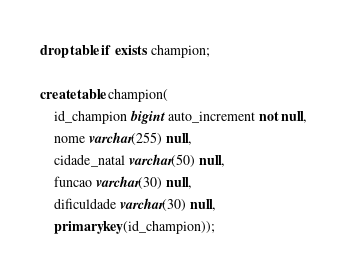<code> <loc_0><loc_0><loc_500><loc_500><_SQL_>drop table if exists champion;

create table champion(
    id_champion bigint auto_increment not null,
    nome varchar(255) null,
    cidade_natal varchar(50) null,
    funcao varchar(30) null,
    dificuldade varchar(30) null,
    primary key(id_champion));</code> 